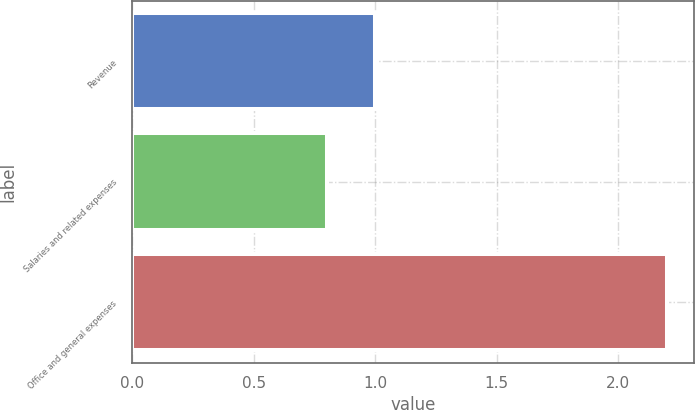Convert chart to OTSL. <chart><loc_0><loc_0><loc_500><loc_500><bar_chart><fcel>Revenue<fcel>Salaries and related expenses<fcel>Office and general expenses<nl><fcel>1<fcel>0.8<fcel>2.2<nl></chart> 